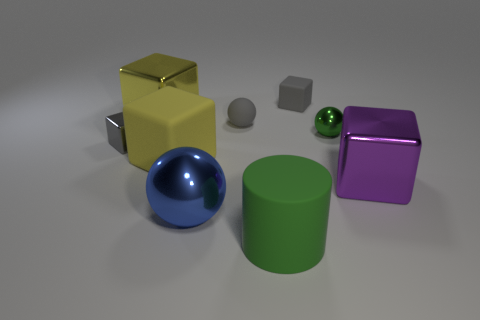Is the tiny metallic sphere the same color as the rubber cylinder?
Your response must be concise. Yes. There is a shiny ball in front of the gray thing on the left side of the tiny gray rubber ball; how many tiny gray blocks are behind it?
Ensure brevity in your answer.  2. The yellow matte object is what size?
Offer a very short reply. Large. What is the material of the green object that is the same size as the purple metal thing?
Your answer should be very brief. Rubber. There is a big yellow matte thing; how many metal things are on the right side of it?
Your answer should be compact. 3. Are the ball in front of the tiny shiny cube and the big object behind the gray ball made of the same material?
Make the answer very short. Yes. There is a gray thing in front of the green shiny object that is right of the thing in front of the blue metal thing; what is its shape?
Offer a very short reply. Cube. There is a small green thing; what shape is it?
Offer a terse response. Sphere. There is a purple metal object that is the same size as the blue object; what shape is it?
Provide a succinct answer. Cube. How many other objects are there of the same color as the small metallic ball?
Give a very brief answer. 1. 